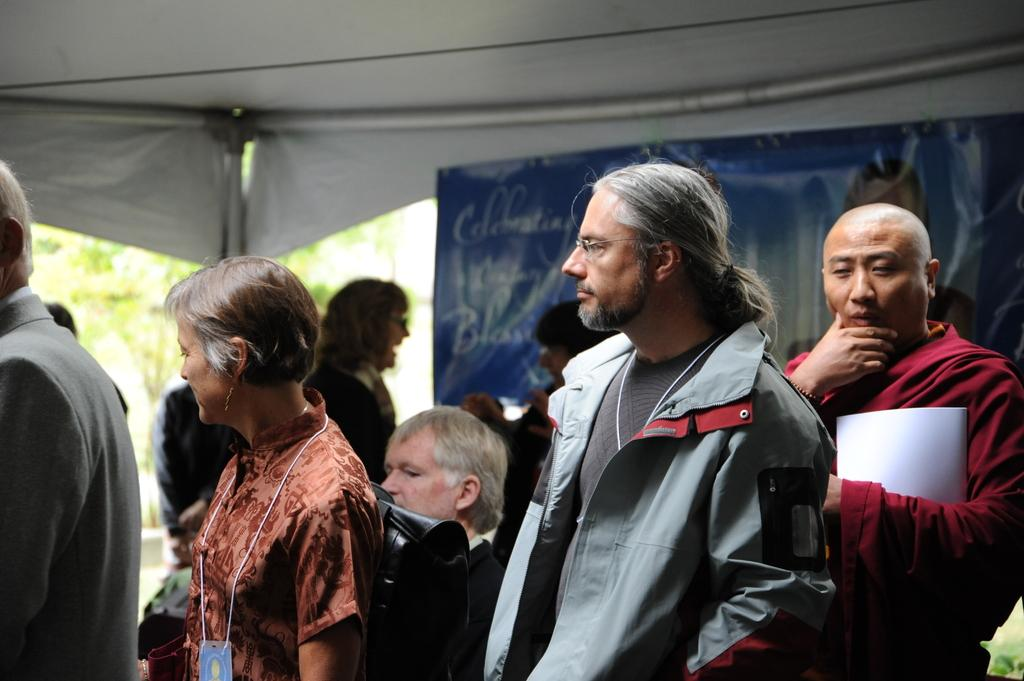Where are the people located in the image? The people are under a tent in the image. What is the man holding in his hand? The man is holding a file in his hand. What can be seen in the background of the image? There are poles, a banner, and trees in the background of the image. What type of pan is being used to cook food in the image? There is no pan or cooking activity present in the image. 